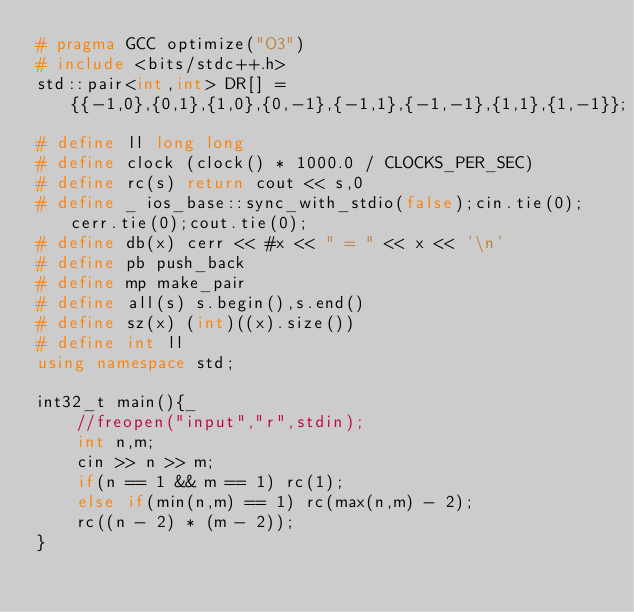Convert code to text. <code><loc_0><loc_0><loc_500><loc_500><_C++_># pragma GCC optimize("O3")
# include <bits/stdc++.h>
std::pair<int,int> DR[] = {{-1,0},{0,1},{1,0},{0,-1},{-1,1},{-1,-1},{1,1},{1,-1}};
# define ll long long
# define clock (clock() * 1000.0 / CLOCKS_PER_SEC)
# define rc(s) return cout << s,0
# define _ ios_base::sync_with_stdio(false);cin.tie(0);cerr.tie(0);cout.tie(0);
# define db(x) cerr << #x << " = " << x << '\n'
# define pb push_back
# define mp make_pair
# define all(s) s.begin(),s.end()
# define sz(x) (int)((x).size())
# define int ll
using namespace std;

int32_t main(){_
    //freopen("input","r",stdin);
	int n,m;
	cin >> n >> m;
	if(n == 1 && m == 1) rc(1);
	else if(min(n,m) == 1) rc(max(n,m) - 2);
	rc((n - 2) * (m - 2));
}</code> 